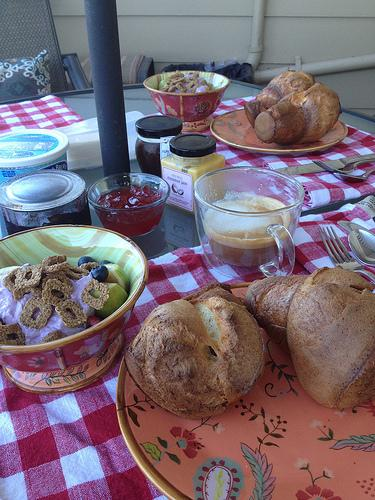Briefly describe the object near the top-right corner of the image. The object near the top-right corner is a silver colored eating utensil, possibly a fork or knife. Describe the pattern on the plate near the center of the image. The plate near the center has a salmon-colored floral print with gold trim. Mention the primary object on which food items are placed in the image. A red white and pink checkered table cloth is placed under the food items. What is unique about the jar near the top-center of the image? The jar near the top-center is clear and contains a yellow substance, possibly a condiment. Name the silverware present in the image and their placement. There is a silver dinner fork placed at the bottom-left and a silver dinner knife at the top-right. Identify the table cloth pattern and color present in the image. The table cloth has a red and white checkered pattern. What is the color and design of the bowl containing some fruit? The bowl containing some fruit has a red and peach floral design. What type of beverage is placed in a transparent glass mug? The transparent glass coffee mug contains a coffee drink, possibly espresso. List three food items that are placed on separate plates. Two potatoes, brown bread, and blueberries with bread in a bowl. What is the main food item on a floral designed bread plate? The main food item on the floral designed bread plate is a large loaf of bread. Can you see a green plate with yellow stripes on the table? The plate is described as having a floral design and gold trim, but there is no mention of a green plate with yellow stripes. Can you find a gold dinner fork in the image? The dinner fork is described as silver, not gold. Is the coffee mug in the image purple and made of porcelain? The mug is described as a clear glass coffee mug, not a purple porcelain one. Are there three potatoes on a plate in the image? There are only two potatoes mentioned on a plate, not three. Is there a bowl of blue jelly on the table? The bowl of jelly is described as red, not blue. Is there a pink polka dot tablecloth on the table? The tablecloth is described as red and white checkered, not pink polka dot. 